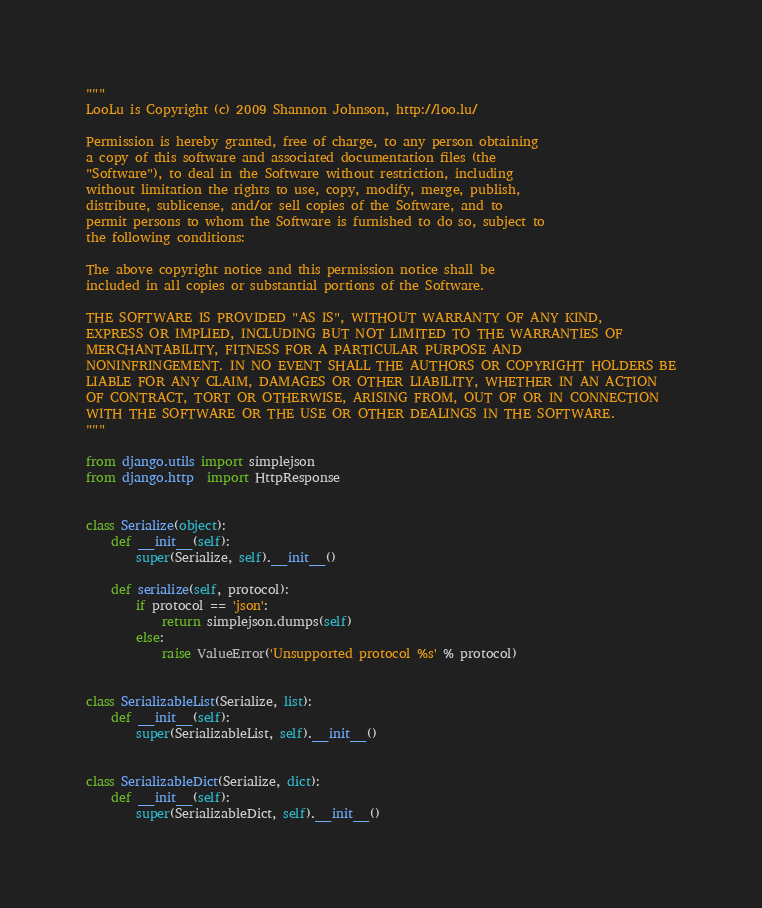Convert code to text. <code><loc_0><loc_0><loc_500><loc_500><_Python_>"""
LooLu is Copyright (c) 2009 Shannon Johnson, http://loo.lu/

Permission is hereby granted, free of charge, to any person obtaining
a copy of this software and associated documentation files (the
"Software"), to deal in the Software without restriction, including
without limitation the rights to use, copy, modify, merge, publish,
distribute, sublicense, and/or sell copies of the Software, and to
permit persons to whom the Software is furnished to do so, subject to
the following conditions:

The above copyright notice and this permission notice shall be
included in all copies or substantial portions of the Software.

THE SOFTWARE IS PROVIDED "AS IS", WITHOUT WARRANTY OF ANY KIND,
EXPRESS OR IMPLIED, INCLUDING BUT NOT LIMITED TO THE WARRANTIES OF
MERCHANTABILITY, FITNESS FOR A PARTICULAR PURPOSE AND
NONINFRINGEMENT. IN NO EVENT SHALL THE AUTHORS OR COPYRIGHT HOLDERS BE
LIABLE FOR ANY CLAIM, DAMAGES OR OTHER LIABILITY, WHETHER IN AN ACTION
OF CONTRACT, TORT OR OTHERWISE, ARISING FROM, OUT OF OR IN CONNECTION
WITH THE SOFTWARE OR THE USE OR OTHER DEALINGS IN THE SOFTWARE.
"""

from django.utils import simplejson
from django.http  import HttpResponse


class Serialize(object):
    def __init__(self):
        super(Serialize, self).__init__()

    def serialize(self, protocol):
        if protocol == 'json':
            return simplejson.dumps(self)
        else:
            raise ValueError('Unsupported protocol %s' % protocol)


class SerializableList(Serialize, list):
    def __init__(self):
        super(SerializableList, self).__init__()


class SerializableDict(Serialize, dict):
    def __init__(self):
        super(SerializableDict, self).__init__()

</code> 